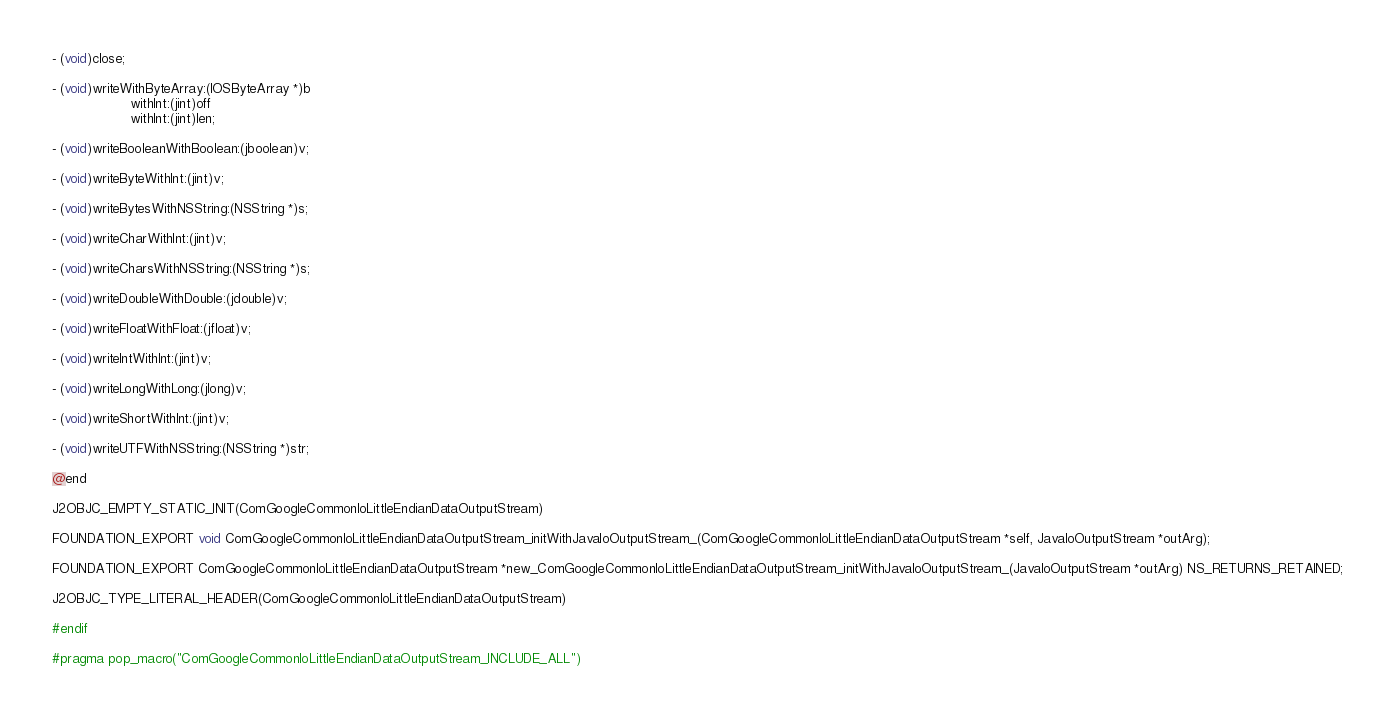Convert code to text. <code><loc_0><loc_0><loc_500><loc_500><_C_>
- (void)close;

- (void)writeWithByteArray:(IOSByteArray *)b
                   withInt:(jint)off
                   withInt:(jint)len;

- (void)writeBooleanWithBoolean:(jboolean)v;

- (void)writeByteWithInt:(jint)v;

- (void)writeBytesWithNSString:(NSString *)s;

- (void)writeCharWithInt:(jint)v;

- (void)writeCharsWithNSString:(NSString *)s;

- (void)writeDoubleWithDouble:(jdouble)v;

- (void)writeFloatWithFloat:(jfloat)v;

- (void)writeIntWithInt:(jint)v;

- (void)writeLongWithLong:(jlong)v;

- (void)writeShortWithInt:(jint)v;

- (void)writeUTFWithNSString:(NSString *)str;

@end

J2OBJC_EMPTY_STATIC_INIT(ComGoogleCommonIoLittleEndianDataOutputStream)

FOUNDATION_EXPORT void ComGoogleCommonIoLittleEndianDataOutputStream_initWithJavaIoOutputStream_(ComGoogleCommonIoLittleEndianDataOutputStream *self, JavaIoOutputStream *outArg);

FOUNDATION_EXPORT ComGoogleCommonIoLittleEndianDataOutputStream *new_ComGoogleCommonIoLittleEndianDataOutputStream_initWithJavaIoOutputStream_(JavaIoOutputStream *outArg) NS_RETURNS_RETAINED;

J2OBJC_TYPE_LITERAL_HEADER(ComGoogleCommonIoLittleEndianDataOutputStream)

#endif

#pragma pop_macro("ComGoogleCommonIoLittleEndianDataOutputStream_INCLUDE_ALL")
</code> 